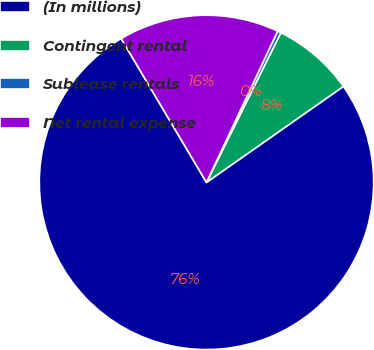Convert chart. <chart><loc_0><loc_0><loc_500><loc_500><pie_chart><fcel>(In millions)<fcel>Contingent rental<fcel>Sublease rentals<fcel>Net rental expense<nl><fcel>76.21%<fcel>7.93%<fcel>0.34%<fcel>15.52%<nl></chart> 